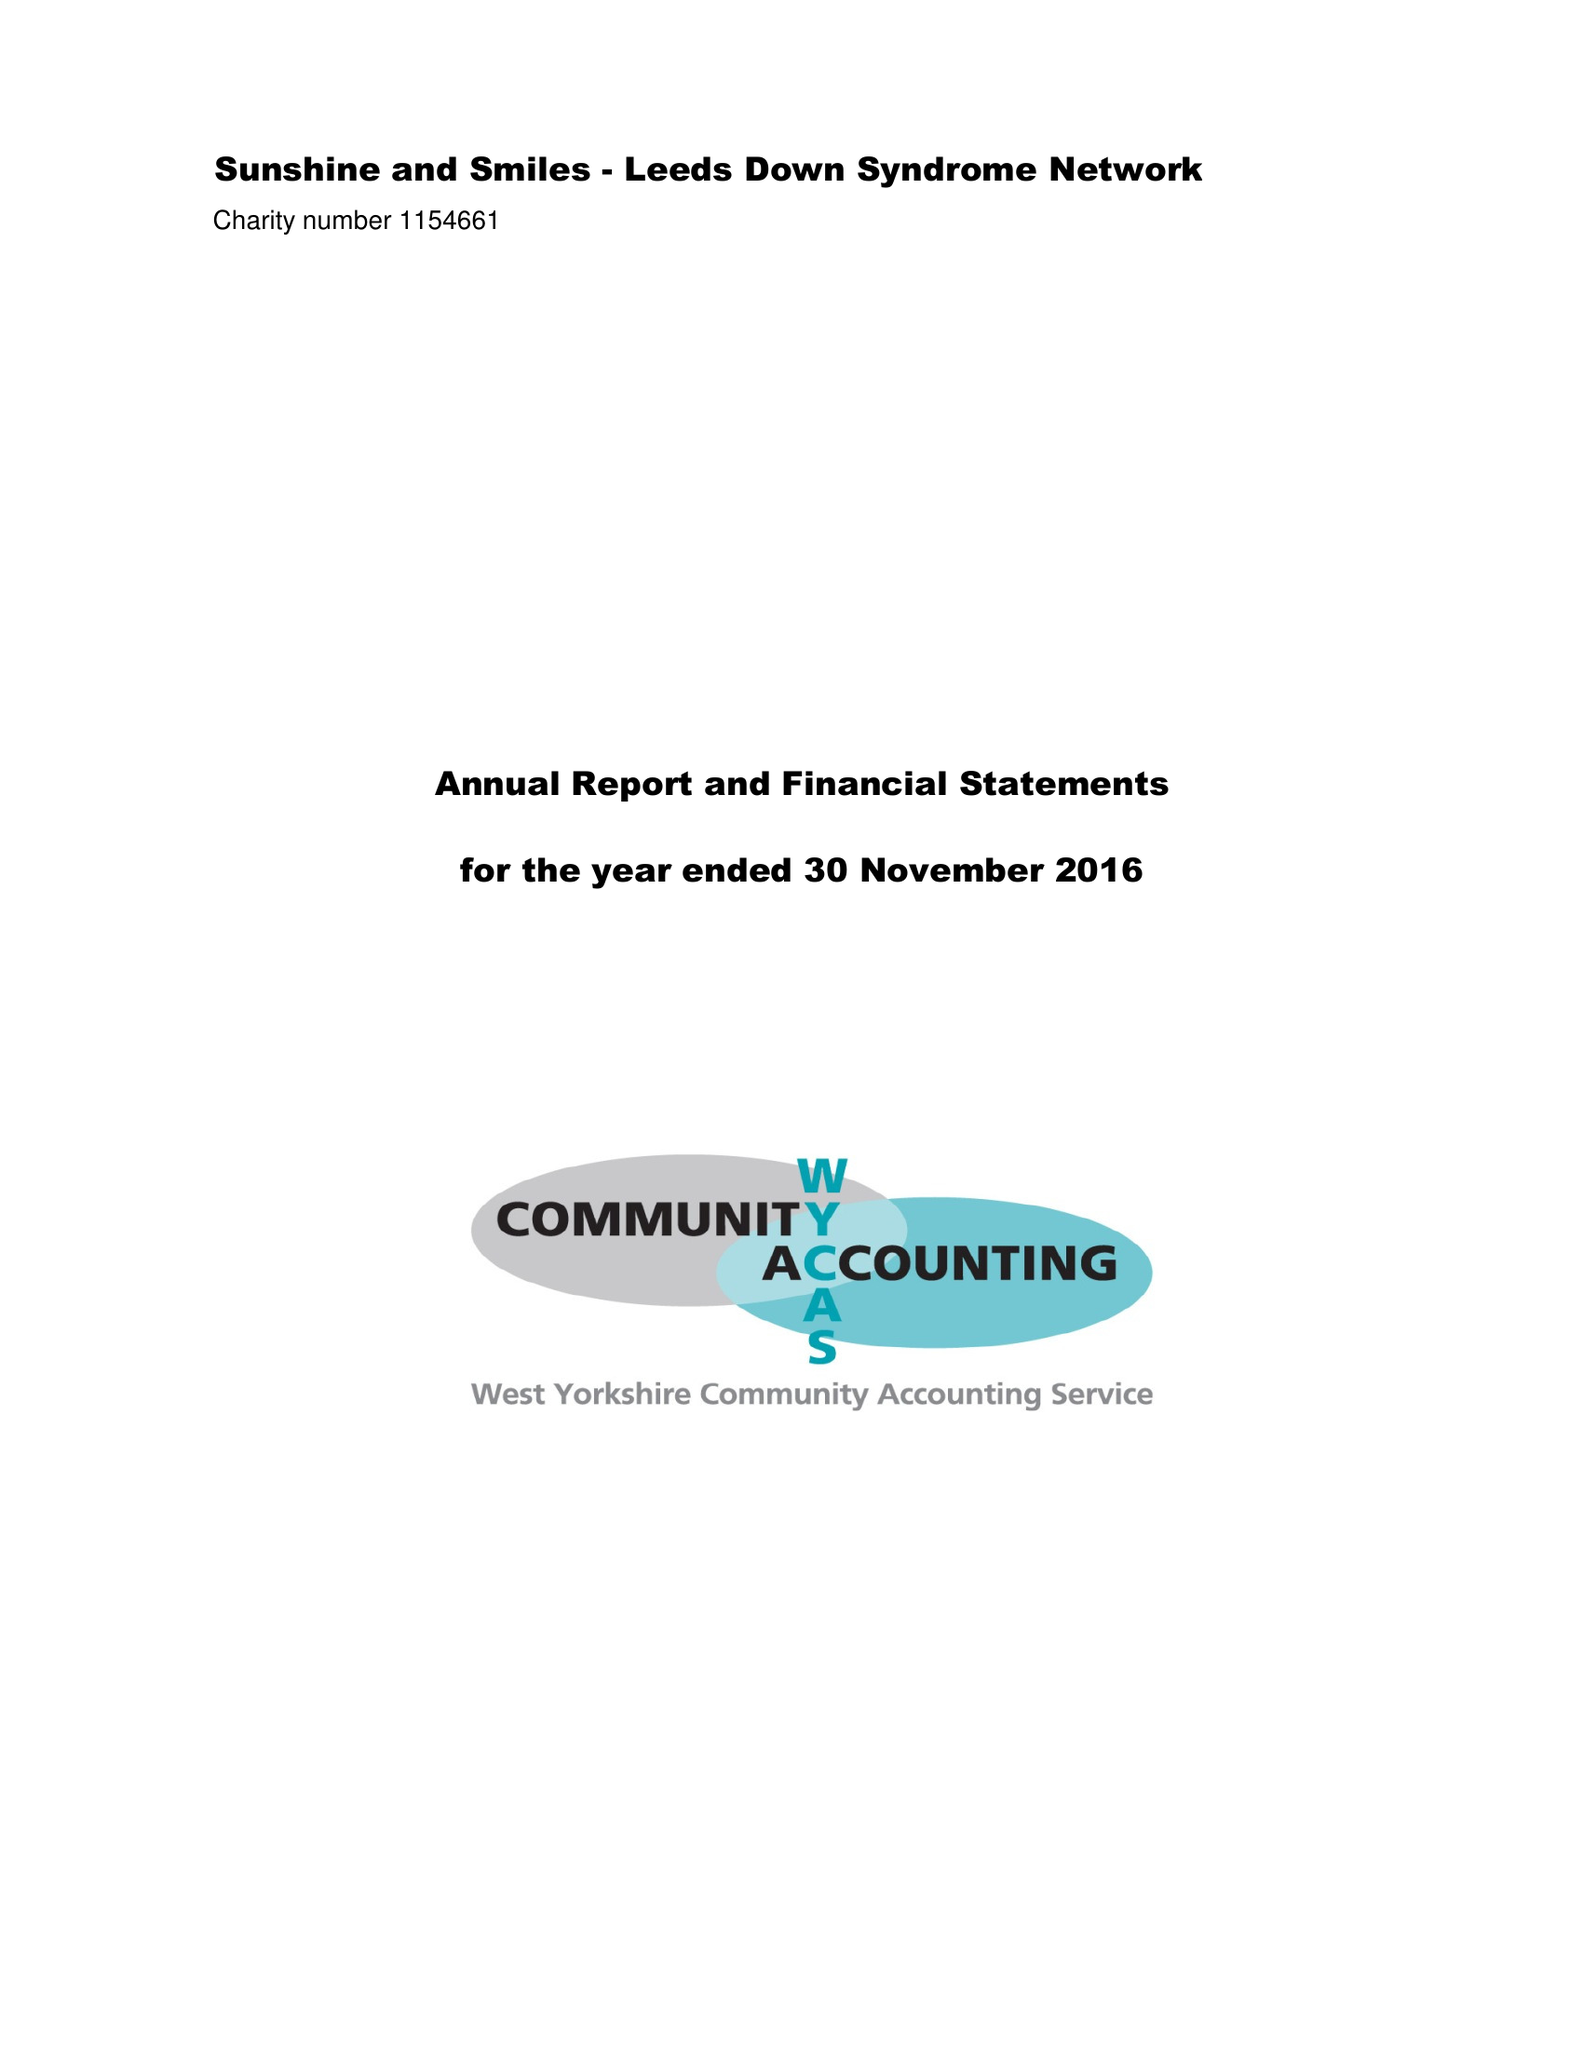What is the value for the income_annually_in_british_pounds?
Answer the question using a single word or phrase. 60013.00 